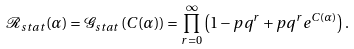<formula> <loc_0><loc_0><loc_500><loc_500>\mathcal { R } _ { s t a t } ( \alpha ) = \mathcal { G } _ { s t a t } \left ( C ( \alpha ) \right ) = \prod _ { r = 0 } ^ { \infty } \left ( 1 - p q ^ { r } + p q ^ { r } e ^ { C ( \alpha ) } \right ) .</formula> 